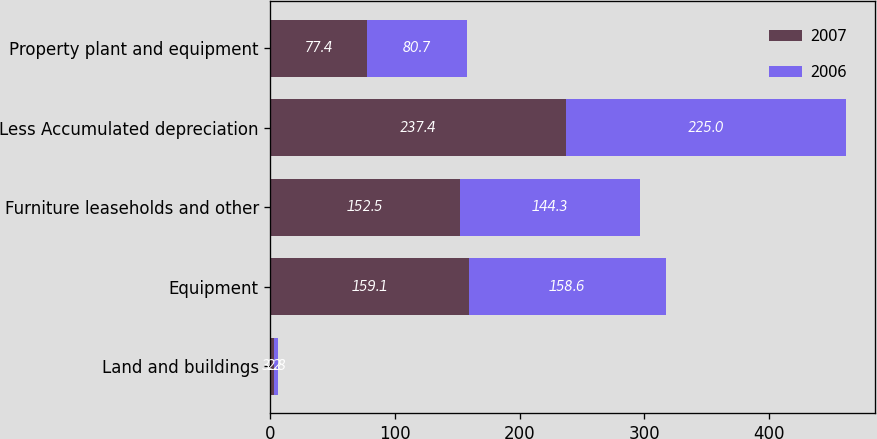Convert chart. <chart><loc_0><loc_0><loc_500><loc_500><stacked_bar_chart><ecel><fcel>Land and buildings<fcel>Equipment<fcel>Furniture leaseholds and other<fcel>Less Accumulated depreciation<fcel>Property plant and equipment<nl><fcel>2007<fcel>3.2<fcel>159.1<fcel>152.5<fcel>237.4<fcel>77.4<nl><fcel>2006<fcel>2.8<fcel>158.6<fcel>144.3<fcel>225<fcel>80.7<nl></chart> 